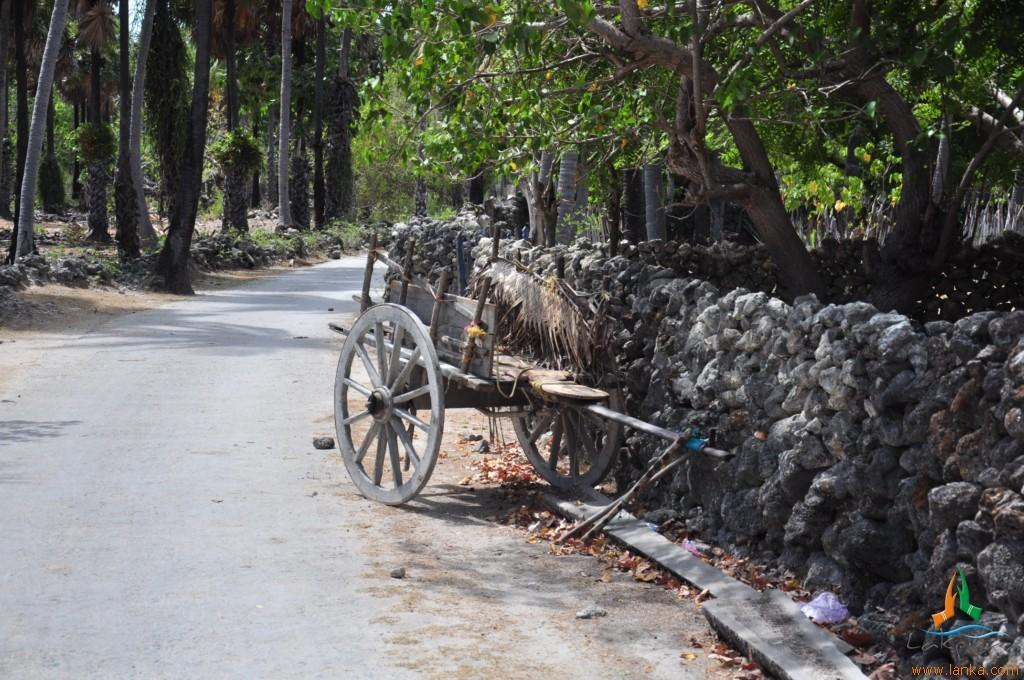What type of vegetation can be seen in the image? There are many trees in the image. What object is made of wood and can be used for transportation? There is a wooden cart in the image. What type of pathway is visible in the image? There is a road in the image. What type of structure can be seen in the image? There is a wall in the image. Where is the prison located in the image? There is no prison present in the image. What type of game is being played in the image? There is no game being played in the image. 